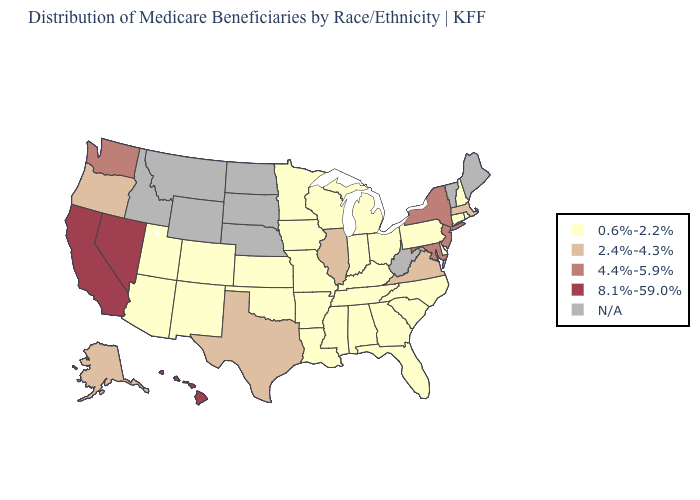Which states have the lowest value in the West?
Give a very brief answer. Arizona, Colorado, New Mexico, Utah. How many symbols are there in the legend?
Give a very brief answer. 5. Name the states that have a value in the range 8.1%-59.0%?
Keep it brief. California, Hawaii, Nevada. What is the highest value in the West ?
Write a very short answer. 8.1%-59.0%. What is the value of California?
Concise answer only. 8.1%-59.0%. What is the highest value in the USA?
Give a very brief answer. 8.1%-59.0%. Name the states that have a value in the range 0.6%-2.2%?
Answer briefly. Alabama, Arizona, Arkansas, Colorado, Connecticut, Delaware, Florida, Georgia, Indiana, Iowa, Kansas, Kentucky, Louisiana, Michigan, Minnesota, Mississippi, Missouri, New Hampshire, New Mexico, North Carolina, Ohio, Oklahoma, Pennsylvania, Rhode Island, South Carolina, Tennessee, Utah, Wisconsin. Which states have the highest value in the USA?
Answer briefly. California, Hawaii, Nevada. Among the states that border Wyoming , which have the highest value?
Be succinct. Colorado, Utah. Name the states that have a value in the range 2.4%-4.3%?
Write a very short answer. Alaska, Illinois, Massachusetts, Oregon, Texas, Virginia. What is the value of Maryland?
Concise answer only. 4.4%-5.9%. 